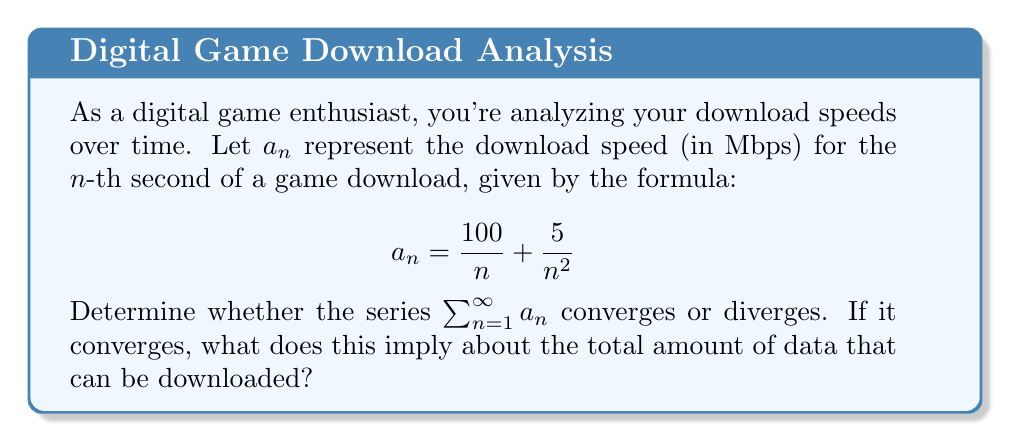What is the answer to this math problem? Let's approach this step-by-step:

1) First, we need to analyze the series $\sum_{n=1}^{\infty} a_n = \sum_{n=1}^{\infty} (\frac{100}{n} + \frac{5}{n^2})$

2) We can split this into two series:
   $$\sum_{n=1}^{\infty} \frac{100}{n} + \sum_{n=1}^{\infty} \frac{5}{n^2}$$

3) Let's analyze each series separately:

   a) $\sum_{n=1}^{\infty} \frac{100}{n}$:
      This is a constant multiple of the harmonic series $\sum_{n=1}^{\infty} \frac{1}{n}$, which is known to diverge.

   b) $\sum_{n=1}^{\infty} \frac{5}{n^2}$:
      This is a constant multiple of the p-series $\sum_{n=1}^{\infty} \frac{1}{n^2}$, which converges for $p > 1$. Here, $p = 2 > 1$, so this series converges.

4) The sum of a divergent series and a convergent series is divergent.

5) Therefore, the original series $\sum_{n=1}^{\infty} a_n$ diverges.

6) In the context of download speeds, this divergence implies that the total amount of data that can be downloaded over an infinite time is unbounded or infinite.
Answer: The series diverges, implying unlimited downloadable data. 